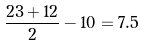Convert formula to latex. <formula><loc_0><loc_0><loc_500><loc_500>\frac { 2 3 + 1 2 } { 2 } - 1 0 = 7 . 5</formula> 